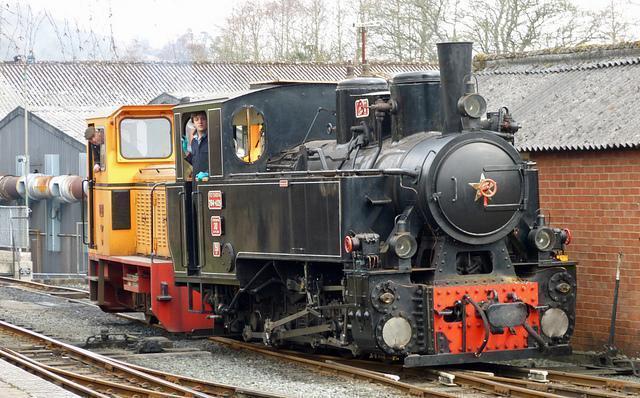Where were the first bricks used?
Pick the right solution, then justify: 'Answer: answer
Rationale: rationale.'
Options: Middle east, spain, britain, america. Answer: middle east.
Rationale: The bricks are in the middle east. 